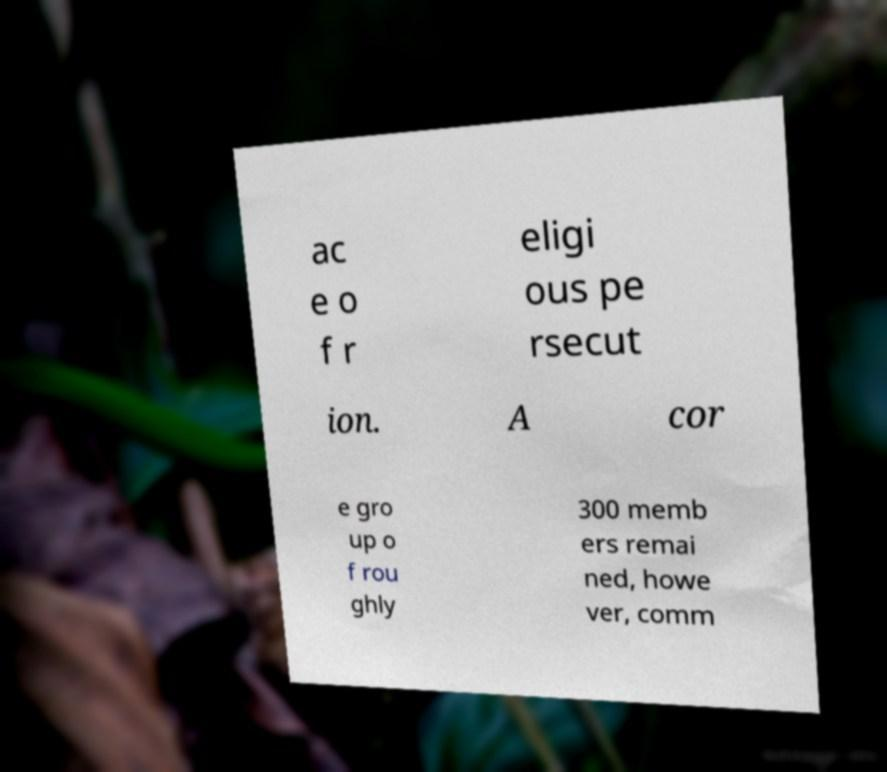For documentation purposes, I need the text within this image transcribed. Could you provide that? ac e o f r eligi ous pe rsecut ion. A cor e gro up o f rou ghly 300 memb ers remai ned, howe ver, comm 